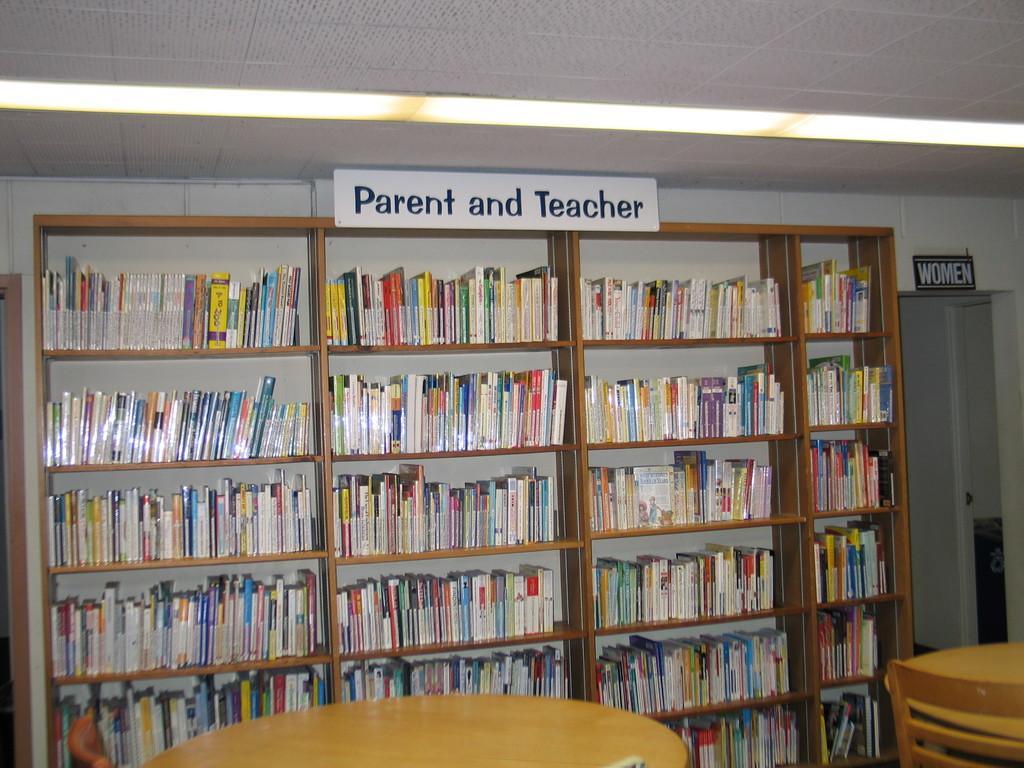In one or two sentences, can you explain what this image depicts? In this image I can see the rack. In the rock there are many books which are colorful. And there is board in the top of the rack and I can see the name parent and teacher is written on it. In-front of the rack I can see the tables and the chair. 